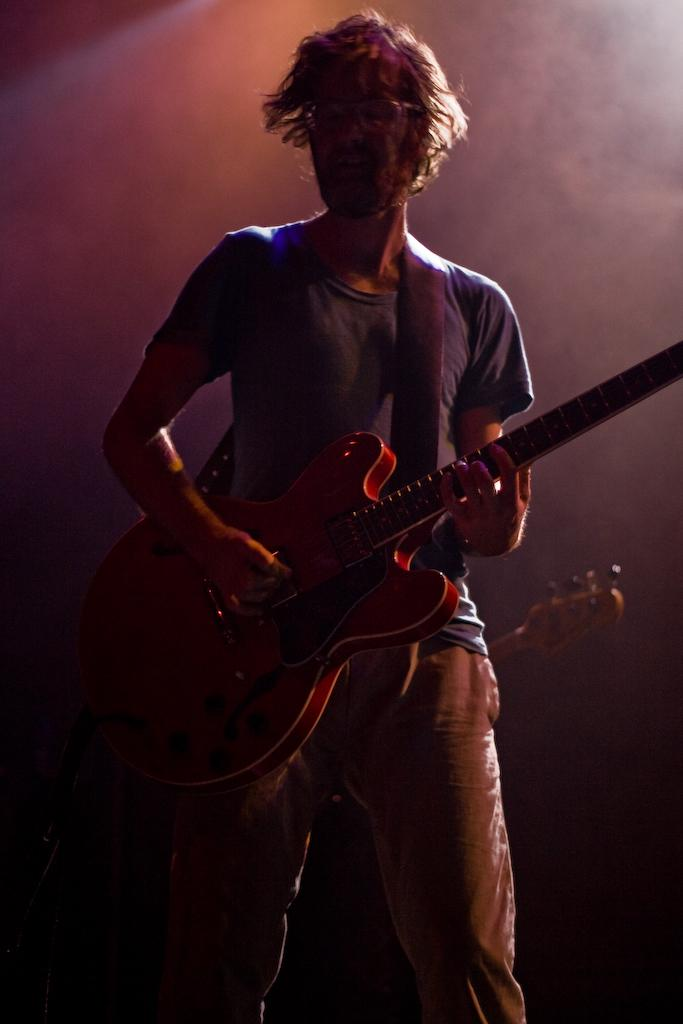What is the main subject of the image? There is a man in the image. What is the man doing in the image? The man is playing a guitar. What type of haircut does the man have in the image? There is no information about the man's haircut in the image. How many horses are present in the image? There are no horses present in the image. 